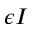<formula> <loc_0><loc_0><loc_500><loc_500>\epsilon I</formula> 